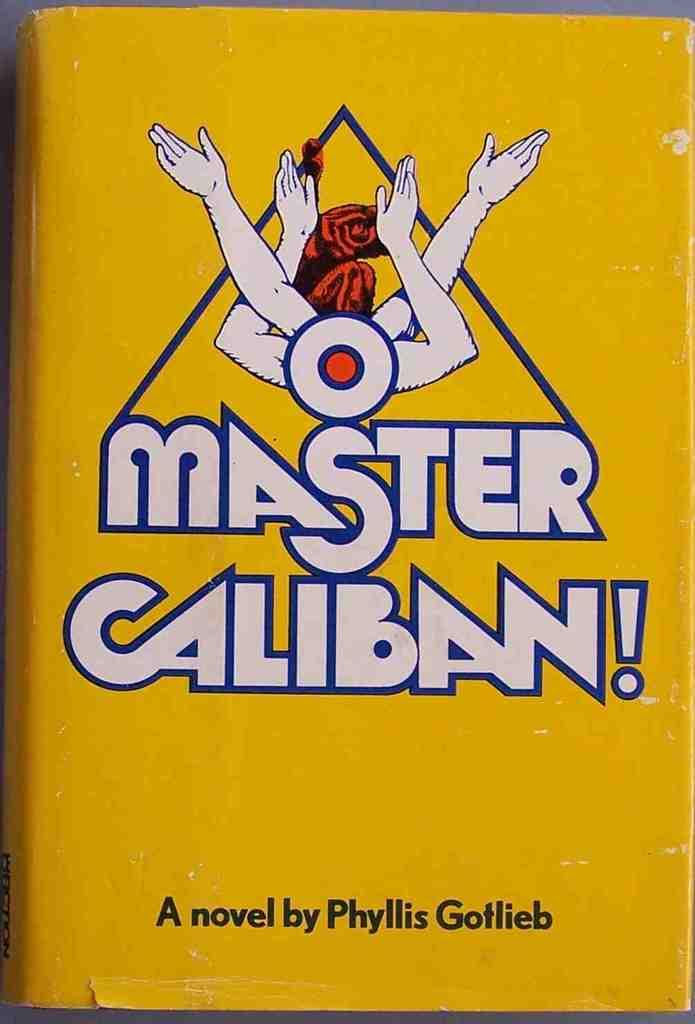What type of item is featured on the cover page in the image? The image contains a cover page of a novel. What is the dominant color of the cover page? The cover page is in yellow color. What color are the words on the cover page? There are white color words and black color words on the cover page. Can you tell me how many roots are visible on the cover page? There are no roots visible on the cover page; it features a novel cover with words and colors. 